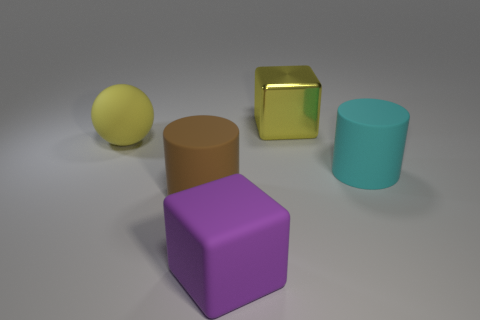What number of brown matte objects are there?
Your answer should be very brief. 1. What number of purple things are made of the same material as the cyan cylinder?
Keep it short and to the point. 1. Are there the same number of big cubes behind the big yellow rubber sphere and small gray objects?
Give a very brief answer. No. There is a big cube that is the same color as the rubber ball; what is its material?
Provide a succinct answer. Metal. What number of other objects are the same size as the cyan matte object?
Give a very brief answer. 4. What number of other things are there of the same color as the large metallic block?
Provide a short and direct response. 1. How many other objects are the same shape as the large purple matte thing?
Make the answer very short. 1. Are there any small green cubes?
Your answer should be very brief. No. Are there any other things that have the same material as the yellow cube?
Make the answer very short. No. Is there a cyan thing made of the same material as the big brown cylinder?
Ensure brevity in your answer.  Yes. 